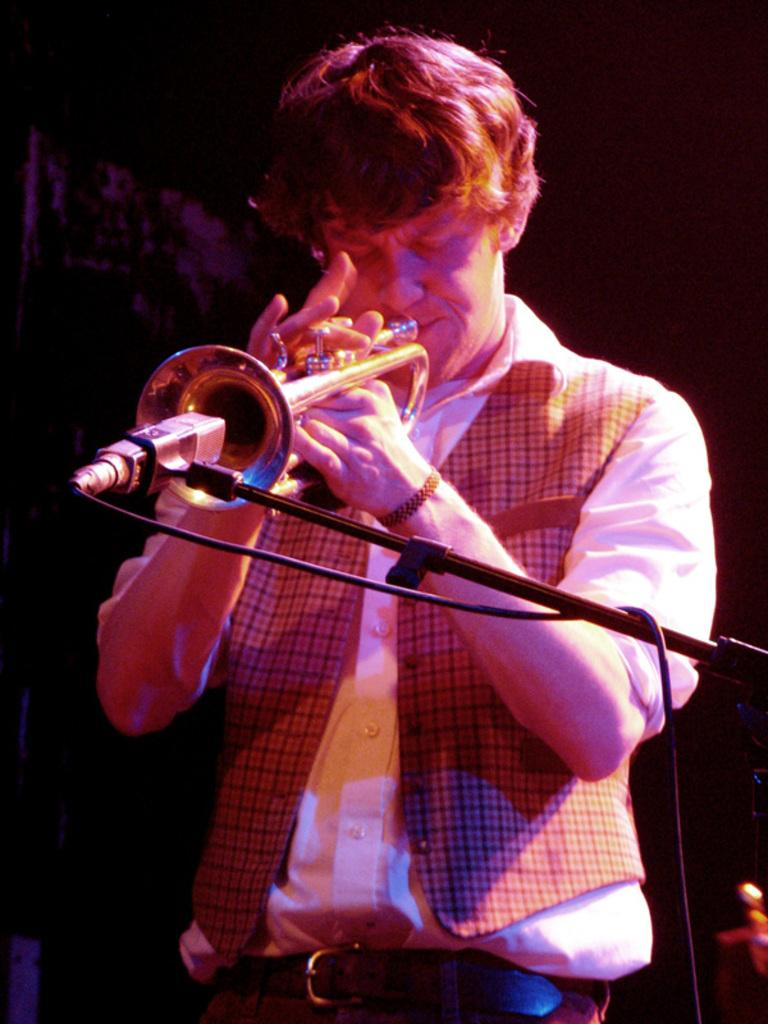Who is the main subject in the image? There is a man in the image. What is the man doing in the image? The man is standing and playing a musical instrument. What is the purpose of the microphone in the image? The microphone is in the image to amplify the sound of the man's musical instrument. How is the microphone positioned in the image? The microphone is on a stand in the image. How many rabbits can be seen playing with ink in the image? There are no rabbits or ink present in the image. 